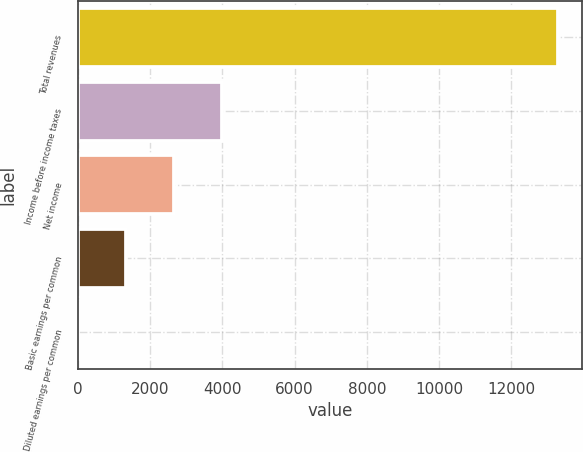Convert chart. <chart><loc_0><loc_0><loc_500><loc_500><bar_chart><fcel>Total revenues<fcel>Income before income taxes<fcel>Net income<fcel>Basic earnings per common<fcel>Diluted earnings per common<nl><fcel>13282<fcel>3987.02<fcel>2659.16<fcel>1331.3<fcel>3.44<nl></chart> 